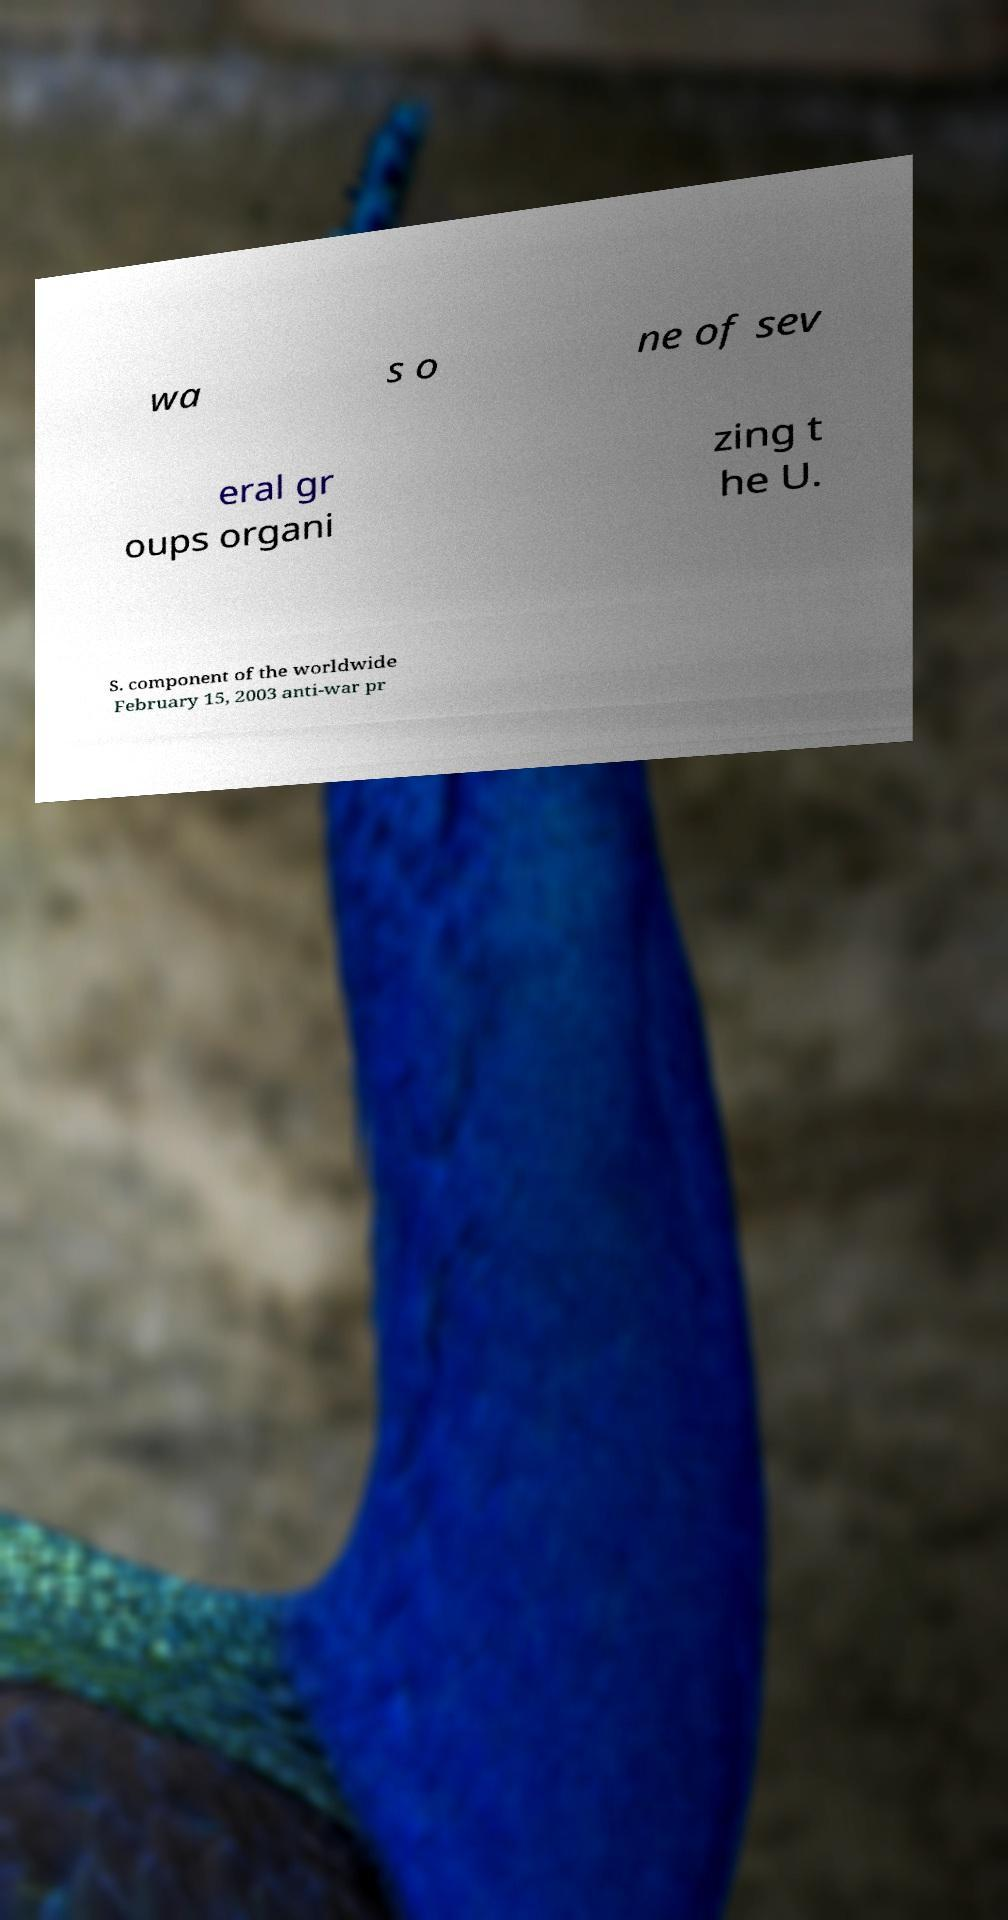Can you read and provide the text displayed in the image?This photo seems to have some interesting text. Can you extract and type it out for me? wa s o ne of sev eral gr oups organi zing t he U. S. component of the worldwide February 15, 2003 anti-war pr 